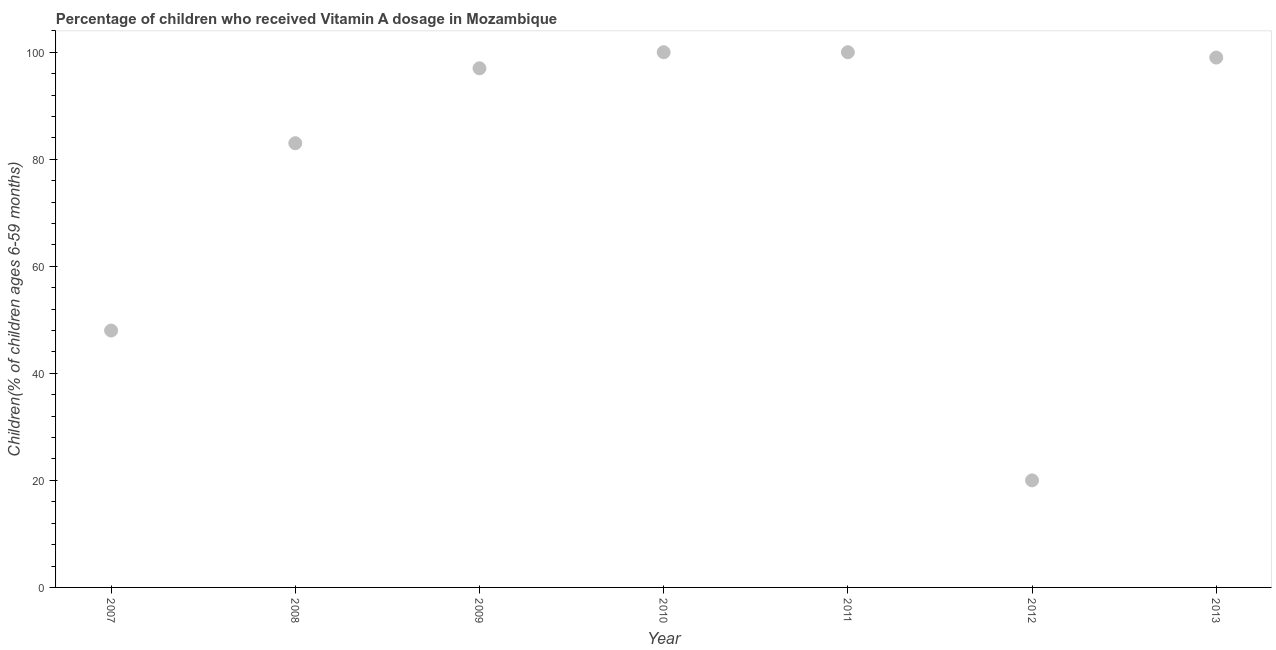What is the vitamin a supplementation coverage rate in 2011?
Your answer should be compact. 100. Across all years, what is the maximum vitamin a supplementation coverage rate?
Offer a very short reply. 100. Across all years, what is the minimum vitamin a supplementation coverage rate?
Offer a terse response. 20. In which year was the vitamin a supplementation coverage rate maximum?
Make the answer very short. 2010. In which year was the vitamin a supplementation coverage rate minimum?
Your response must be concise. 2012. What is the sum of the vitamin a supplementation coverage rate?
Your answer should be compact. 547. What is the difference between the vitamin a supplementation coverage rate in 2010 and 2011?
Provide a short and direct response. 0. What is the average vitamin a supplementation coverage rate per year?
Offer a very short reply. 78.14. What is the median vitamin a supplementation coverage rate?
Make the answer very short. 97. In how many years, is the vitamin a supplementation coverage rate greater than 32 %?
Offer a very short reply. 6. Do a majority of the years between 2013 and 2010 (inclusive) have vitamin a supplementation coverage rate greater than 44 %?
Your answer should be compact. Yes. What is the ratio of the vitamin a supplementation coverage rate in 2009 to that in 2010?
Keep it short and to the point. 0.97. Is the difference between the vitamin a supplementation coverage rate in 2009 and 2011 greater than the difference between any two years?
Your answer should be compact. No. Is the sum of the vitamin a supplementation coverage rate in 2008 and 2012 greater than the maximum vitamin a supplementation coverage rate across all years?
Provide a short and direct response. Yes. What is the difference between the highest and the lowest vitamin a supplementation coverage rate?
Ensure brevity in your answer.  80. In how many years, is the vitamin a supplementation coverage rate greater than the average vitamin a supplementation coverage rate taken over all years?
Keep it short and to the point. 5. What is the difference between two consecutive major ticks on the Y-axis?
Give a very brief answer. 20. Are the values on the major ticks of Y-axis written in scientific E-notation?
Offer a terse response. No. Does the graph contain grids?
Keep it short and to the point. No. What is the title of the graph?
Provide a short and direct response. Percentage of children who received Vitamin A dosage in Mozambique. What is the label or title of the X-axis?
Keep it short and to the point. Year. What is the label or title of the Y-axis?
Provide a short and direct response. Children(% of children ages 6-59 months). What is the Children(% of children ages 6-59 months) in 2008?
Provide a succinct answer. 83. What is the Children(% of children ages 6-59 months) in 2009?
Keep it short and to the point. 97. What is the Children(% of children ages 6-59 months) in 2010?
Your response must be concise. 100. What is the Children(% of children ages 6-59 months) in 2012?
Offer a terse response. 20. What is the Children(% of children ages 6-59 months) in 2013?
Your response must be concise. 99. What is the difference between the Children(% of children ages 6-59 months) in 2007 and 2008?
Offer a very short reply. -35. What is the difference between the Children(% of children ages 6-59 months) in 2007 and 2009?
Keep it short and to the point. -49. What is the difference between the Children(% of children ages 6-59 months) in 2007 and 2010?
Ensure brevity in your answer.  -52. What is the difference between the Children(% of children ages 6-59 months) in 2007 and 2011?
Offer a terse response. -52. What is the difference between the Children(% of children ages 6-59 months) in 2007 and 2012?
Make the answer very short. 28. What is the difference between the Children(% of children ages 6-59 months) in 2007 and 2013?
Give a very brief answer. -51. What is the difference between the Children(% of children ages 6-59 months) in 2008 and 2010?
Give a very brief answer. -17. What is the difference between the Children(% of children ages 6-59 months) in 2008 and 2012?
Your answer should be compact. 63. What is the difference between the Children(% of children ages 6-59 months) in 2009 and 2012?
Offer a very short reply. 77. What is the difference between the Children(% of children ages 6-59 months) in 2010 and 2011?
Make the answer very short. 0. What is the difference between the Children(% of children ages 6-59 months) in 2010 and 2012?
Your answer should be compact. 80. What is the difference between the Children(% of children ages 6-59 months) in 2011 and 2012?
Offer a very short reply. 80. What is the difference between the Children(% of children ages 6-59 months) in 2012 and 2013?
Give a very brief answer. -79. What is the ratio of the Children(% of children ages 6-59 months) in 2007 to that in 2008?
Give a very brief answer. 0.58. What is the ratio of the Children(% of children ages 6-59 months) in 2007 to that in 2009?
Make the answer very short. 0.49. What is the ratio of the Children(% of children ages 6-59 months) in 2007 to that in 2010?
Keep it short and to the point. 0.48. What is the ratio of the Children(% of children ages 6-59 months) in 2007 to that in 2011?
Keep it short and to the point. 0.48. What is the ratio of the Children(% of children ages 6-59 months) in 2007 to that in 2013?
Provide a succinct answer. 0.48. What is the ratio of the Children(% of children ages 6-59 months) in 2008 to that in 2009?
Give a very brief answer. 0.86. What is the ratio of the Children(% of children ages 6-59 months) in 2008 to that in 2010?
Your response must be concise. 0.83. What is the ratio of the Children(% of children ages 6-59 months) in 2008 to that in 2011?
Provide a succinct answer. 0.83. What is the ratio of the Children(% of children ages 6-59 months) in 2008 to that in 2012?
Make the answer very short. 4.15. What is the ratio of the Children(% of children ages 6-59 months) in 2008 to that in 2013?
Give a very brief answer. 0.84. What is the ratio of the Children(% of children ages 6-59 months) in 2009 to that in 2010?
Your response must be concise. 0.97. What is the ratio of the Children(% of children ages 6-59 months) in 2009 to that in 2011?
Offer a very short reply. 0.97. What is the ratio of the Children(% of children ages 6-59 months) in 2009 to that in 2012?
Make the answer very short. 4.85. What is the ratio of the Children(% of children ages 6-59 months) in 2010 to that in 2011?
Ensure brevity in your answer.  1. What is the ratio of the Children(% of children ages 6-59 months) in 2010 to that in 2012?
Give a very brief answer. 5. What is the ratio of the Children(% of children ages 6-59 months) in 2010 to that in 2013?
Keep it short and to the point. 1.01. What is the ratio of the Children(% of children ages 6-59 months) in 2011 to that in 2012?
Give a very brief answer. 5. What is the ratio of the Children(% of children ages 6-59 months) in 2012 to that in 2013?
Offer a very short reply. 0.2. 